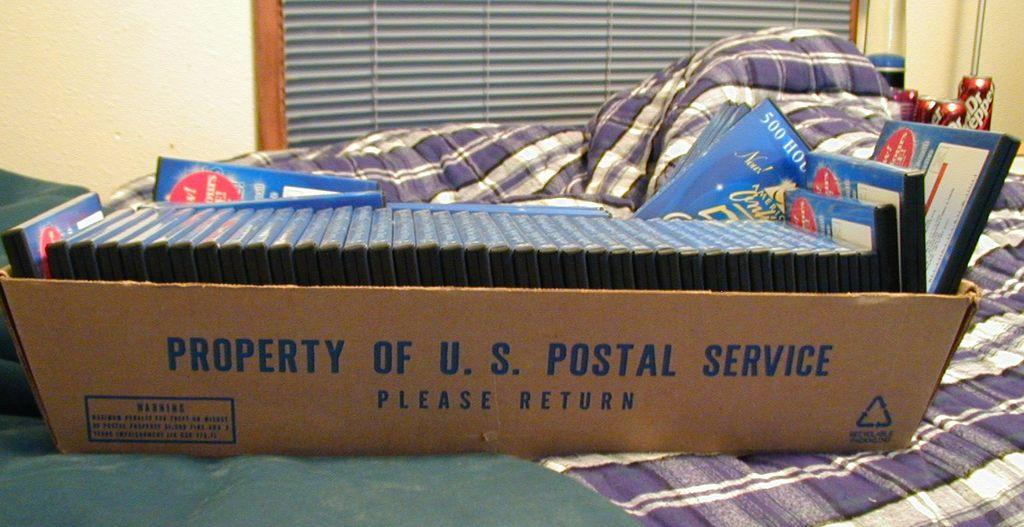What is the main object in the image? There is a cardboard carton in the image. What is inside the carton? The carton is filled with discs. Where is the carton placed? The carton is placed on a cot. What can be seen in the background of the image? There are blinds, walls, and beverage tins in the background of the image. Can you see any icicles hanging from the gate in the image? There is no gate present in the image, and therefore no icicles can be seen hanging from it. 